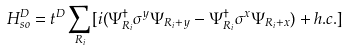Convert formula to latex. <formula><loc_0><loc_0><loc_500><loc_500>H _ { s o } ^ { D } = t ^ { D } \sum _ { R _ { i } } [ i ( \Psi _ { R _ { i } } ^ { \dag } \sigma ^ { y } \Psi _ { R _ { i } + y } - \Psi _ { R _ { i } } ^ { \dag } \sigma ^ { x } \Psi _ { R _ { i } + x } ) + h . c . ]</formula> 